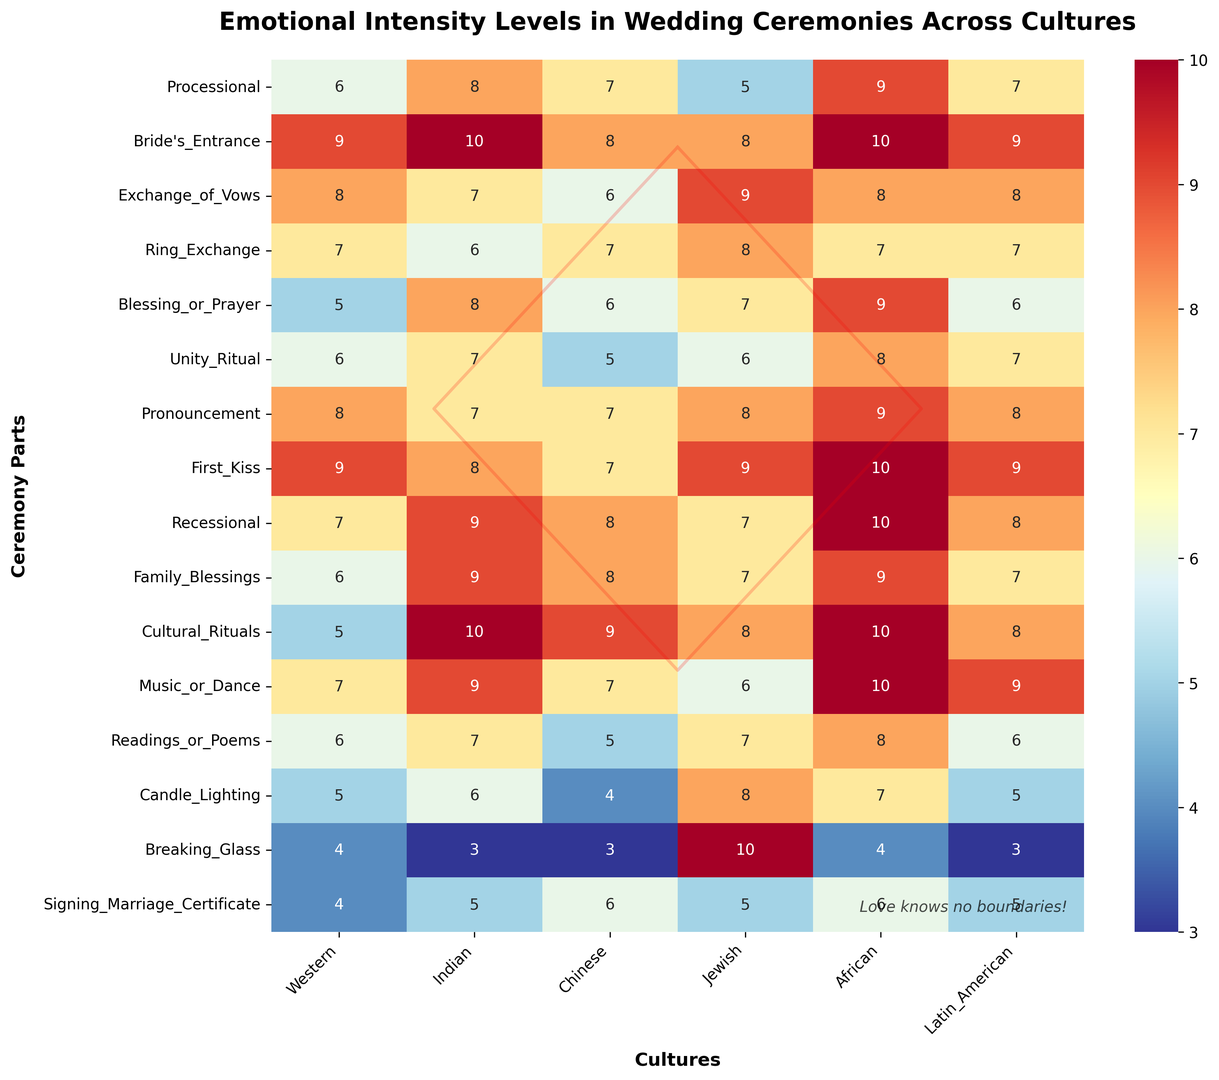Which culture has the highest emotional intensity during the Bride's Entrance? Look for the Bride's Entrance row and identify the highest value across the cultures. The Bride's Entrance in Indian and African cultures both have an emotional intensity level of 10, which is the highest.
Answer: Indian, African What is the average emotional intensity of the Processional across all cultures? Sum the values of the Processional row (6+8+7+5+9+7) and divide by the number of cultures (6). The sum is 42, and the average is 42/6 = 7.
Answer: 7 Which parts of the ceremony have an emotional intensity of 10 in African culture? Check the African column and identify the parts with the value 10. The Bride's Entrance, First Kiss, Recessional, Cultural Rituals, and Music or Dance all have an emotional intensity of 10.
Answer: Bride's Entrance, First Kiss, Recessional, Cultural Rituals, Music or Dance How does the emotional intensity of the First Kiss compare between Western and Jewish cultures? Look at the First Kiss row for both the Western and Jewish columns. The emotional intensity for the Western culture is 9, while for the Jewish culture it is also 9. Therefore, they have the same emotional intensity level.
Answer: Equal What is the range of emotional intensity values for Jewish culture across all parts of the ceremony? Identify the minimum and maximum values in the Jewish column. The minimum is 5 (Processional) and the maximum is 10 (Breaking Glass). The range is 10 - 5 = 5.
Answer: 5 Which ceremony part has the lowest emotional intensity across all cultures? Identify the minimum value across the entire heatmap. The lowest values are in the Breaking Glass part for Western, Chinese, and Latin American cultures, all having a value of 3.
Answer: Breaking Glass How many ceremony parts have an emotional intensity of 9 in Latin American culture? Check the Latin American column and count the parts with the value 9. The parts are Bride's Entrance, First Kiss, Music or Dance, and Pronouncement, making a total of 4 parts.
Answer: 4 What is the combined emotional intensity for Family Blessings and Cultural Rituals in Indian culture? Add the values for Family Blessings (9) and Cultural Rituals (10) in the Indian column. The total is 9 + 10 = 19.
Answer: 19 Which ceremony parts have the same emotional intensity level in Western and Chinese cultures? Compare the values in the Western and Chinese columns. The ceremony parts that have the same values are Exchange of Vows (8), Ring Exchange (7), Family Blessings (6), Cultural Rituals (5), and Music or Dance (7).
Answer: Exchange of Vows, Ring Exchange, Family Blessings, Cultural Rituals, Music or Dance 